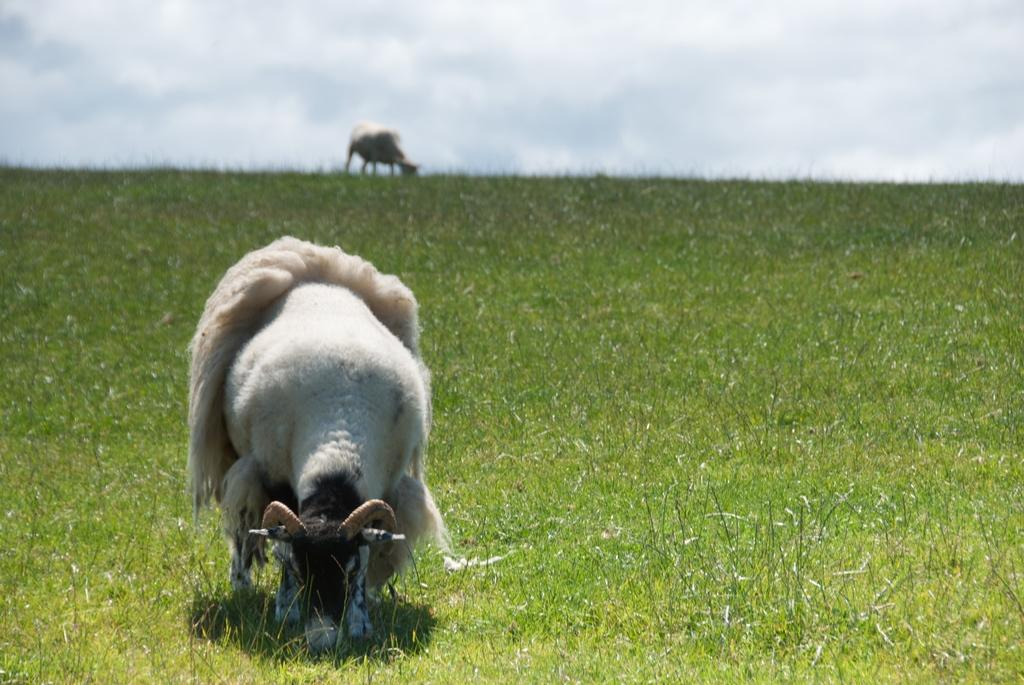How many animals are present in the image? There are two animals in the image. Where are the animals located? The animals are on the grass. What can be seen in the background of the image? The sky is visible in the background of the image. What type of design or art can be seen on the animals in the image? There is no specific design or art mentioned on the animals in the image. 